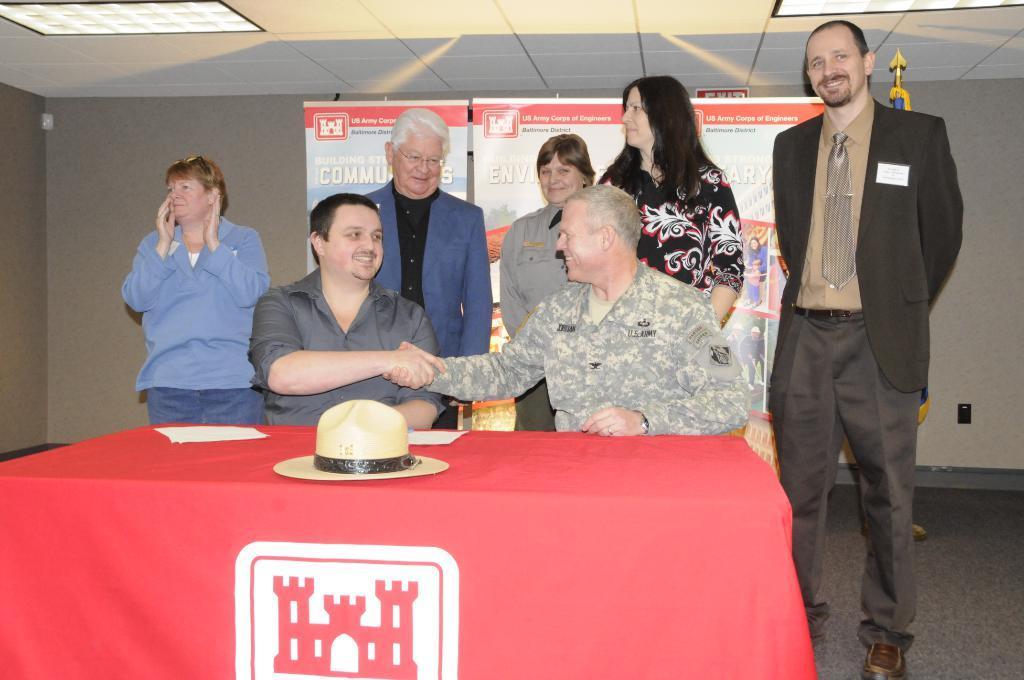Describe this image in one or two sentences. In the image we can see there are two men who are sitting on chair. On the table there is a hat and at the back there are lot of people standing 